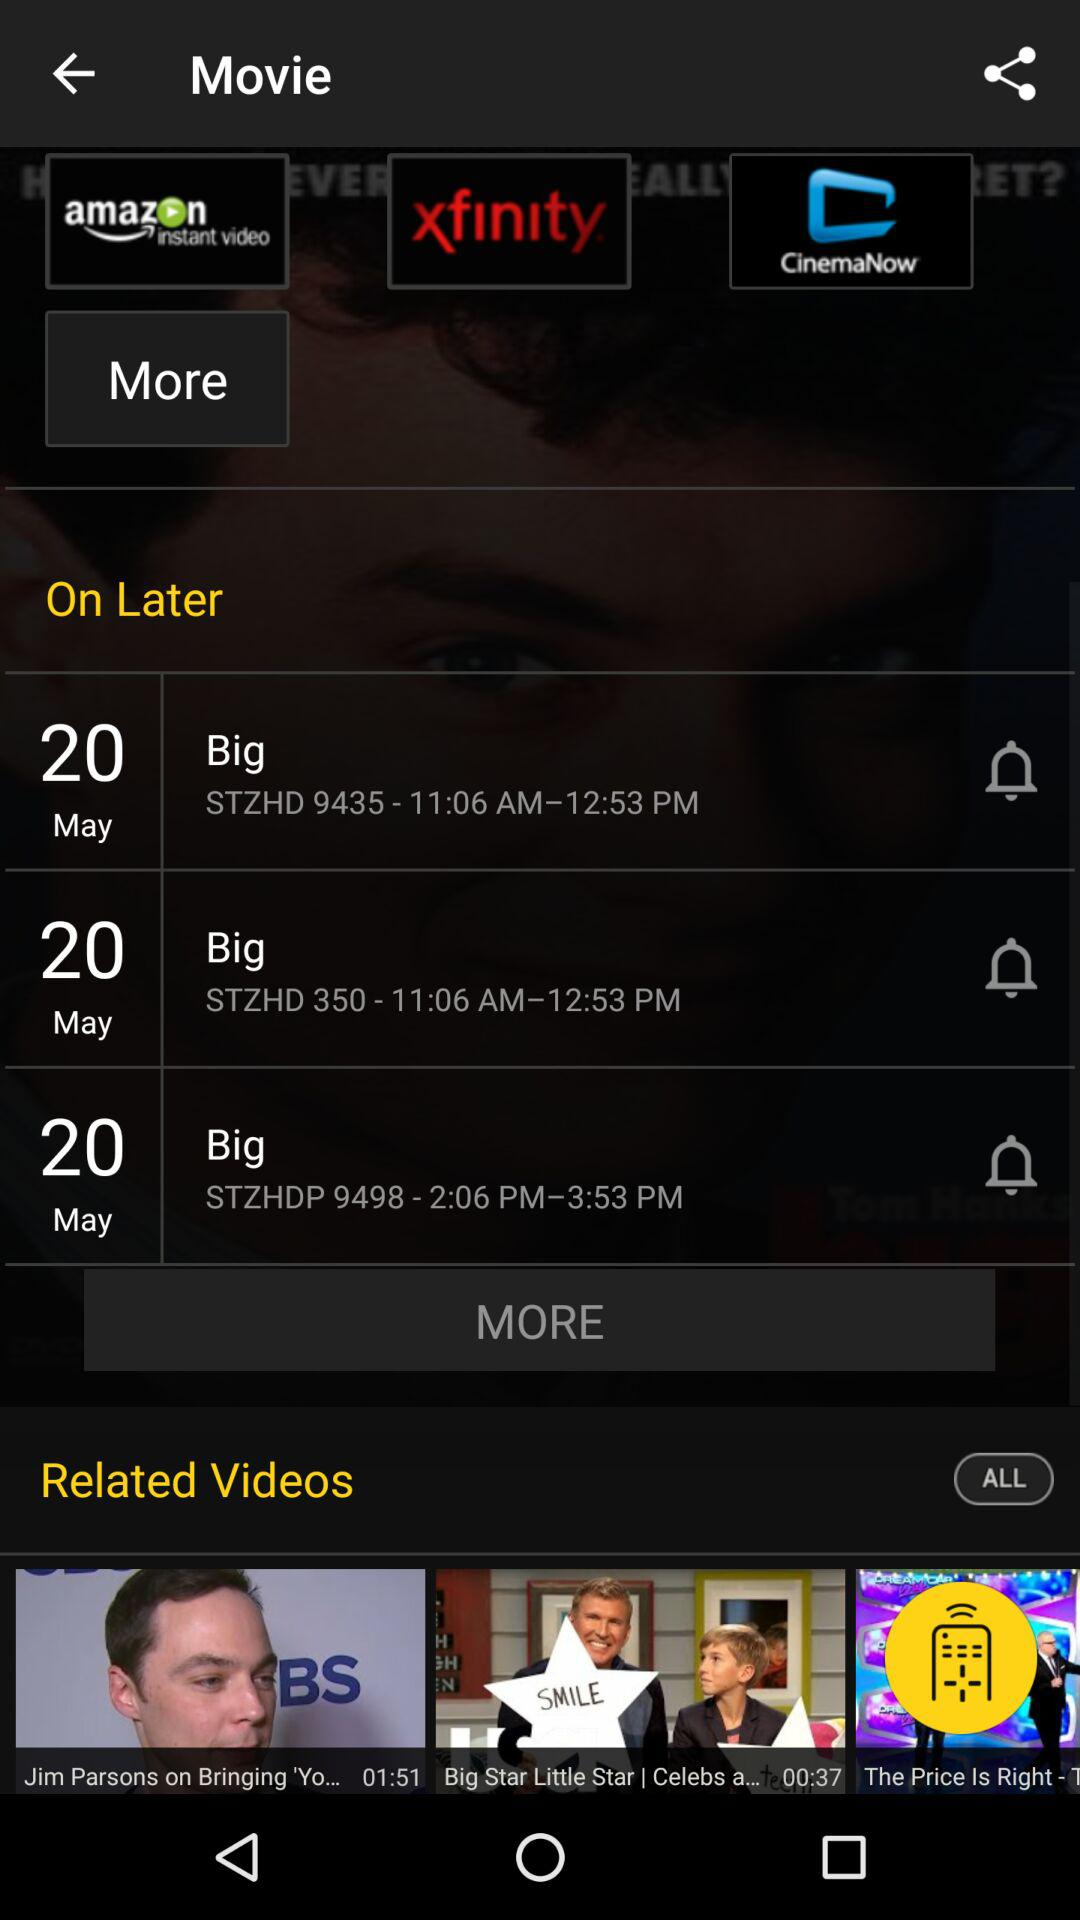What is the date for "STZHD 9435 - 11:06 AM—12:53 PM"? The date is May 20. 